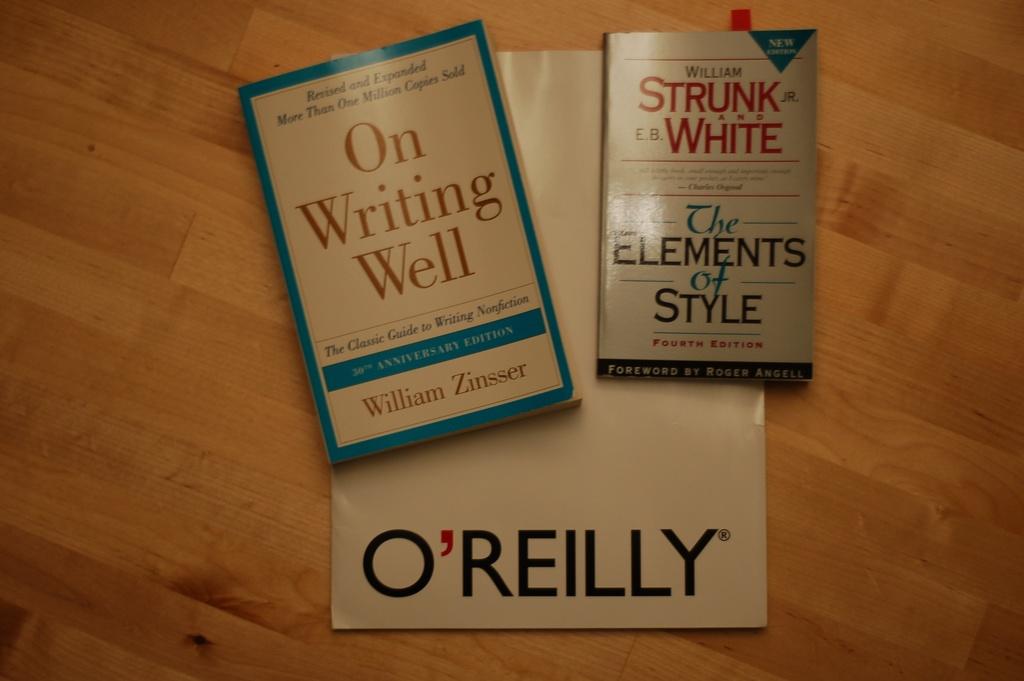Who wrote on writing well?
Your answer should be very brief. William zinsser. What is the book's name on the right side?
Offer a terse response. The elements of style. 